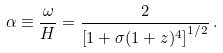<formula> <loc_0><loc_0><loc_500><loc_500>\alpha \equiv \frac { \omega } { H } = \frac { 2 } { \left [ 1 + \sigma ( 1 + z ) ^ { 4 } \right ] ^ { 1 / 2 } } \, .</formula> 